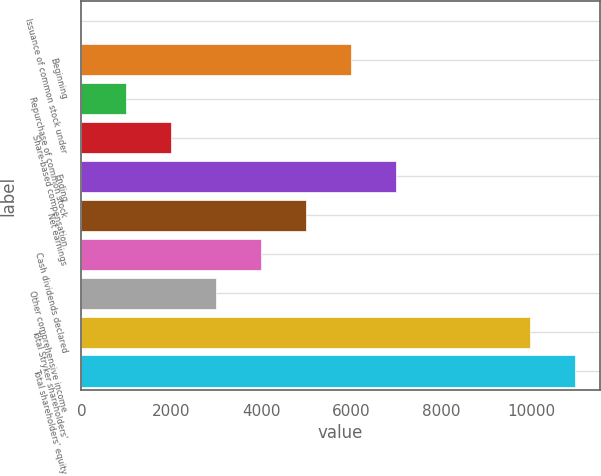Convert chart. <chart><loc_0><loc_0><loc_500><loc_500><bar_chart><fcel>Issuance of common stock under<fcel>Beginning<fcel>Repurchase of common stock<fcel>Share-based compensation<fcel>Ending<fcel>Net earnings<fcel>Cash dividends declared<fcel>Other comprehensive income<fcel>Total Stryker shareholders'<fcel>Total shareholders' equity<nl><fcel>1.7<fcel>5988.68<fcel>999.53<fcel>1997.36<fcel>6986.51<fcel>4990.85<fcel>3993.02<fcel>2995.19<fcel>9966<fcel>10963.8<nl></chart> 